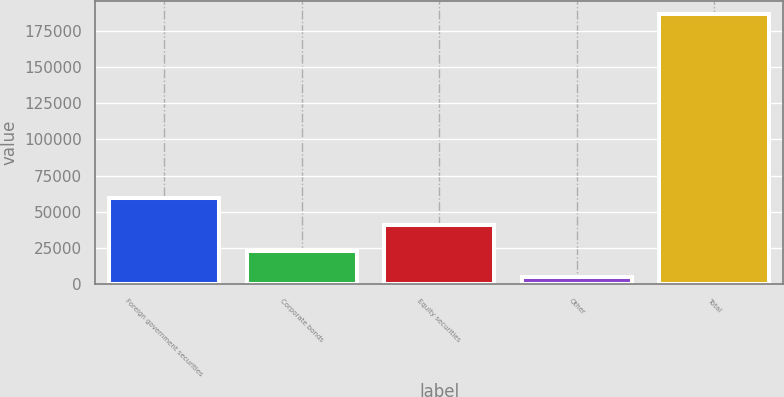<chart> <loc_0><loc_0><loc_500><loc_500><bar_chart><fcel>Foreign government securities<fcel>Corporate bonds<fcel>Equity securities<fcel>Other<fcel>Total<nl><fcel>59238.1<fcel>22890.7<fcel>41064.4<fcel>4717<fcel>186454<nl></chart> 